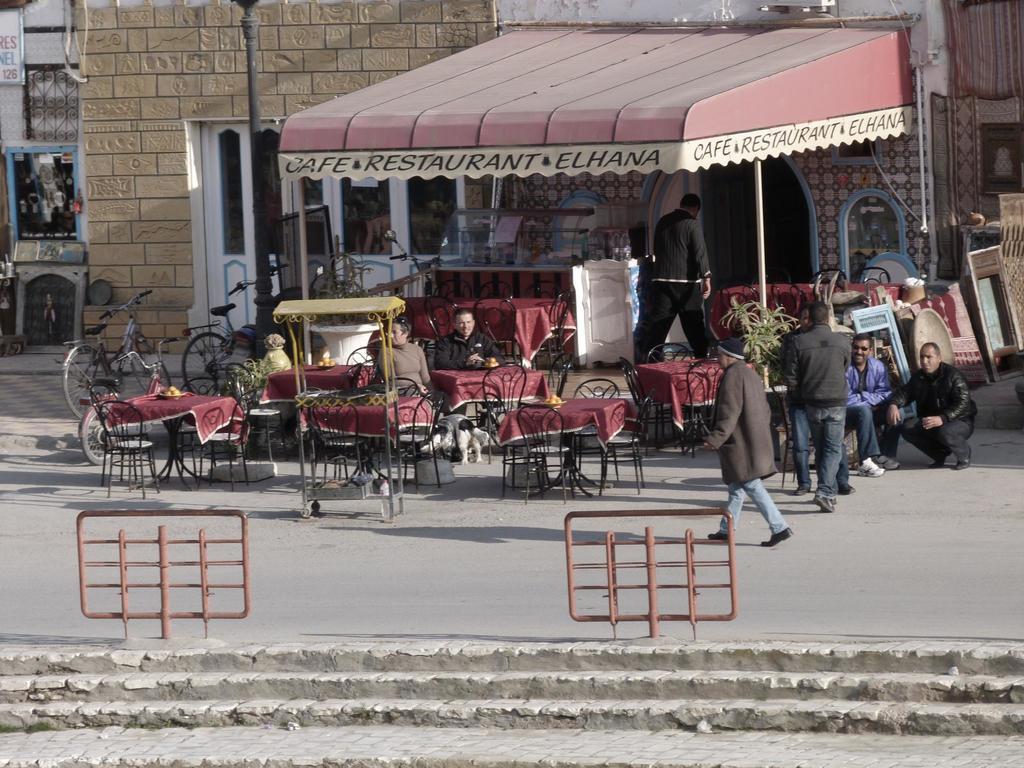Please provide a concise description of this image. In this picture there are two persons sitting on the chair, beside there is an animal. There are few chairs and tables. A person is walking on the road and a person is walking inside to the restaurant. Few persons are at the right side of the image. There is a staircase at the bottom of the image. There are few bicycles at the left side of the image on the pavement. 